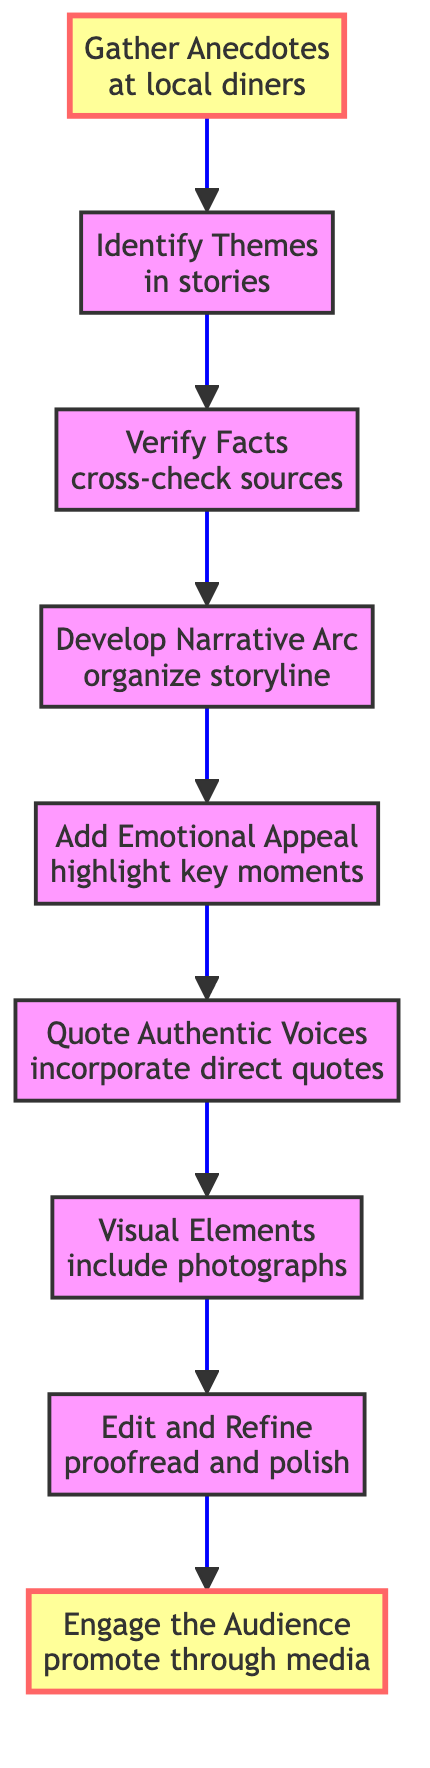What is the first step in the flowchart? The first step listed in the flowchart is "Gather Anecdotes". This node is positioned at the bottom of the diagram, indicating it's the starting point of the process.
Answer: Gather Anecdotes How many nodes are in the flowchart? To determine the number of nodes, we can count each individual step outlined in the flowchart. There are a total of nine nodes from "Gather Anecdotes" to "Engage the Audience".
Answer: 9 What is the last step indicated in the flowchart? The last step in the flowchart is "Engage the Audience". It is located at the top of the diagram, signifying the final action in the process.
Answer: Engage the Audience What connects "Add Emotional Appeal" to "Quote Authentic Voices"? The connection between "Add Emotional Appeal" and "Quote Authentic Voices" is represented by a directional arrow showing the flow from one step to the next.
Answer: An arrow Which step comes after "Verify Facts"? The step that follows "Verify Facts" in the diagram is "Develop Narrative Arc". This shows the progression of actions taken after verifying the anecdotes.
Answer: Develop Narrative Arc What do the highlighted nodes signify? The highlighted nodes, which are "Gather Anecdotes" and "Engage the Audience", indicate key starting and ending points in the flowchart process, emphasizing their importance in the instruction sequence.
Answer: Key points How many steps focus on storytelling elements? To find the number of steps focusing on storytelling elements, we can identify nodes related to narrative and emotional content. There are four such steps: "Develop Narrative Arc", "Add Emotional Appeal", "Quote Authentic Voices", and "Visual Elements".
Answer: 4 What is the purpose of including visual elements in the story? The purpose of including visual elements, as stated in the flowchart, is to "complement the story visually," enhancing the storytelling through imagery that engages the audience.
Answer: To complement the story visually How does the flowchart suggest to ensure the anecdotes' accuracy? The flowchart suggests ensuring the anecdotes' accuracy by "Verify Facts" through cross-checking sources and public records, a critical step before developing the narrative.
Answer: By verifying facts 